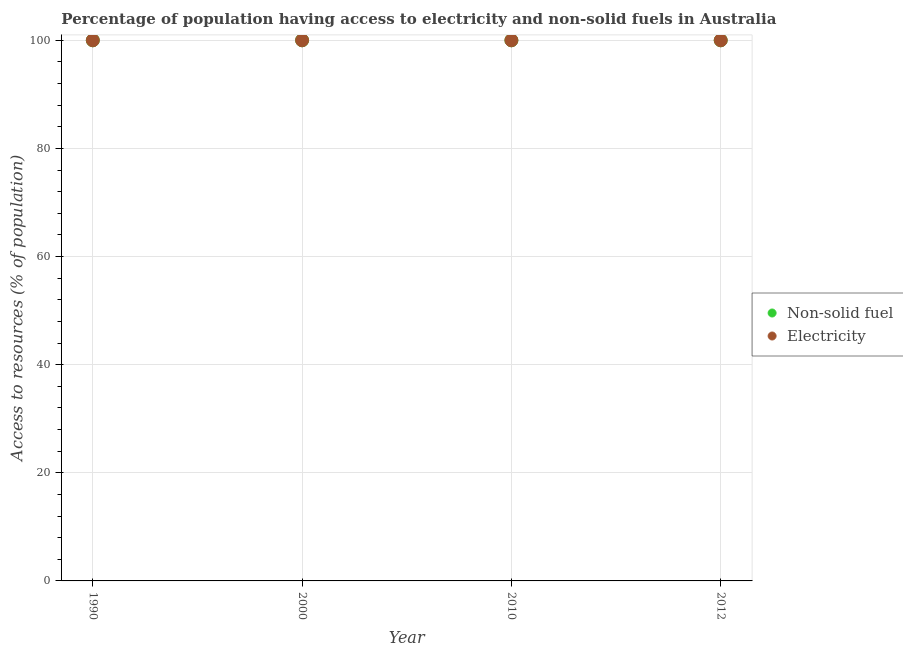How many different coloured dotlines are there?
Make the answer very short. 2. Is the number of dotlines equal to the number of legend labels?
Give a very brief answer. Yes. What is the percentage of population having access to non-solid fuel in 2000?
Your answer should be compact. 100. Across all years, what is the maximum percentage of population having access to electricity?
Provide a succinct answer. 100. Across all years, what is the minimum percentage of population having access to non-solid fuel?
Your response must be concise. 100. What is the total percentage of population having access to electricity in the graph?
Your answer should be very brief. 400. What is the difference between the percentage of population having access to non-solid fuel in 2010 and that in 2012?
Your answer should be very brief. 0. What is the difference between the percentage of population having access to non-solid fuel in 2012 and the percentage of population having access to electricity in 2000?
Your response must be concise. 0. In how many years, is the percentage of population having access to electricity greater than 24 %?
Provide a succinct answer. 4. What is the difference between the highest and the second highest percentage of population having access to non-solid fuel?
Give a very brief answer. 0. In how many years, is the percentage of population having access to non-solid fuel greater than the average percentage of population having access to non-solid fuel taken over all years?
Give a very brief answer. 0. Is the sum of the percentage of population having access to electricity in 2000 and 2010 greater than the maximum percentage of population having access to non-solid fuel across all years?
Give a very brief answer. Yes. Does the percentage of population having access to non-solid fuel monotonically increase over the years?
Provide a short and direct response. No. Is the percentage of population having access to electricity strictly greater than the percentage of population having access to non-solid fuel over the years?
Offer a very short reply. No. How many dotlines are there?
Make the answer very short. 2. How many years are there in the graph?
Ensure brevity in your answer.  4. Are the values on the major ticks of Y-axis written in scientific E-notation?
Provide a short and direct response. No. Does the graph contain any zero values?
Provide a short and direct response. No. Does the graph contain grids?
Give a very brief answer. Yes. How many legend labels are there?
Keep it short and to the point. 2. What is the title of the graph?
Offer a very short reply. Percentage of population having access to electricity and non-solid fuels in Australia. What is the label or title of the Y-axis?
Your response must be concise. Access to resources (% of population). What is the Access to resources (% of population) of Electricity in 1990?
Your answer should be very brief. 100. What is the Access to resources (% of population) of Non-solid fuel in 2000?
Offer a terse response. 100. What is the Access to resources (% of population) in Electricity in 2000?
Offer a very short reply. 100. What is the Access to resources (% of population) in Non-solid fuel in 2010?
Provide a succinct answer. 100. What is the Access to resources (% of population) of Electricity in 2010?
Provide a short and direct response. 100. Across all years, what is the maximum Access to resources (% of population) in Electricity?
Your answer should be very brief. 100. What is the difference between the Access to resources (% of population) of Non-solid fuel in 1990 and that in 2000?
Your answer should be compact. 0. What is the difference between the Access to resources (% of population) in Electricity in 1990 and that in 2000?
Provide a short and direct response. 0. What is the difference between the Access to resources (% of population) of Non-solid fuel in 1990 and that in 2012?
Your answer should be compact. 0. What is the difference between the Access to resources (% of population) of Non-solid fuel in 2000 and that in 2010?
Make the answer very short. 0. What is the difference between the Access to resources (% of population) in Electricity in 2000 and that in 2012?
Provide a succinct answer. 0. What is the difference between the Access to resources (% of population) of Non-solid fuel in 2000 and the Access to resources (% of population) of Electricity in 2012?
Make the answer very short. 0. What is the difference between the Access to resources (% of population) in Non-solid fuel in 2010 and the Access to resources (% of population) in Electricity in 2012?
Give a very brief answer. 0. What is the average Access to resources (% of population) of Electricity per year?
Your answer should be very brief. 100. In the year 2000, what is the difference between the Access to resources (% of population) in Non-solid fuel and Access to resources (% of population) in Electricity?
Your answer should be compact. 0. In the year 2010, what is the difference between the Access to resources (% of population) in Non-solid fuel and Access to resources (% of population) in Electricity?
Your answer should be compact. 0. What is the ratio of the Access to resources (% of population) in Non-solid fuel in 1990 to that in 2000?
Provide a short and direct response. 1. What is the ratio of the Access to resources (% of population) of Electricity in 1990 to that in 2000?
Provide a short and direct response. 1. What is the ratio of the Access to resources (% of population) of Electricity in 1990 to that in 2010?
Give a very brief answer. 1. What is the ratio of the Access to resources (% of population) of Non-solid fuel in 1990 to that in 2012?
Provide a succinct answer. 1. What is the ratio of the Access to resources (% of population) in Electricity in 1990 to that in 2012?
Your answer should be compact. 1. What is the ratio of the Access to resources (% of population) of Non-solid fuel in 2000 to that in 2010?
Offer a very short reply. 1. What is the ratio of the Access to resources (% of population) in Non-solid fuel in 2000 to that in 2012?
Provide a succinct answer. 1. What is the ratio of the Access to resources (% of population) of Electricity in 2000 to that in 2012?
Your answer should be compact. 1. What is the ratio of the Access to resources (% of population) of Electricity in 2010 to that in 2012?
Offer a very short reply. 1. What is the difference between the highest and the second highest Access to resources (% of population) in Non-solid fuel?
Provide a succinct answer. 0. What is the difference between the highest and the lowest Access to resources (% of population) in Non-solid fuel?
Make the answer very short. 0. What is the difference between the highest and the lowest Access to resources (% of population) of Electricity?
Give a very brief answer. 0. 